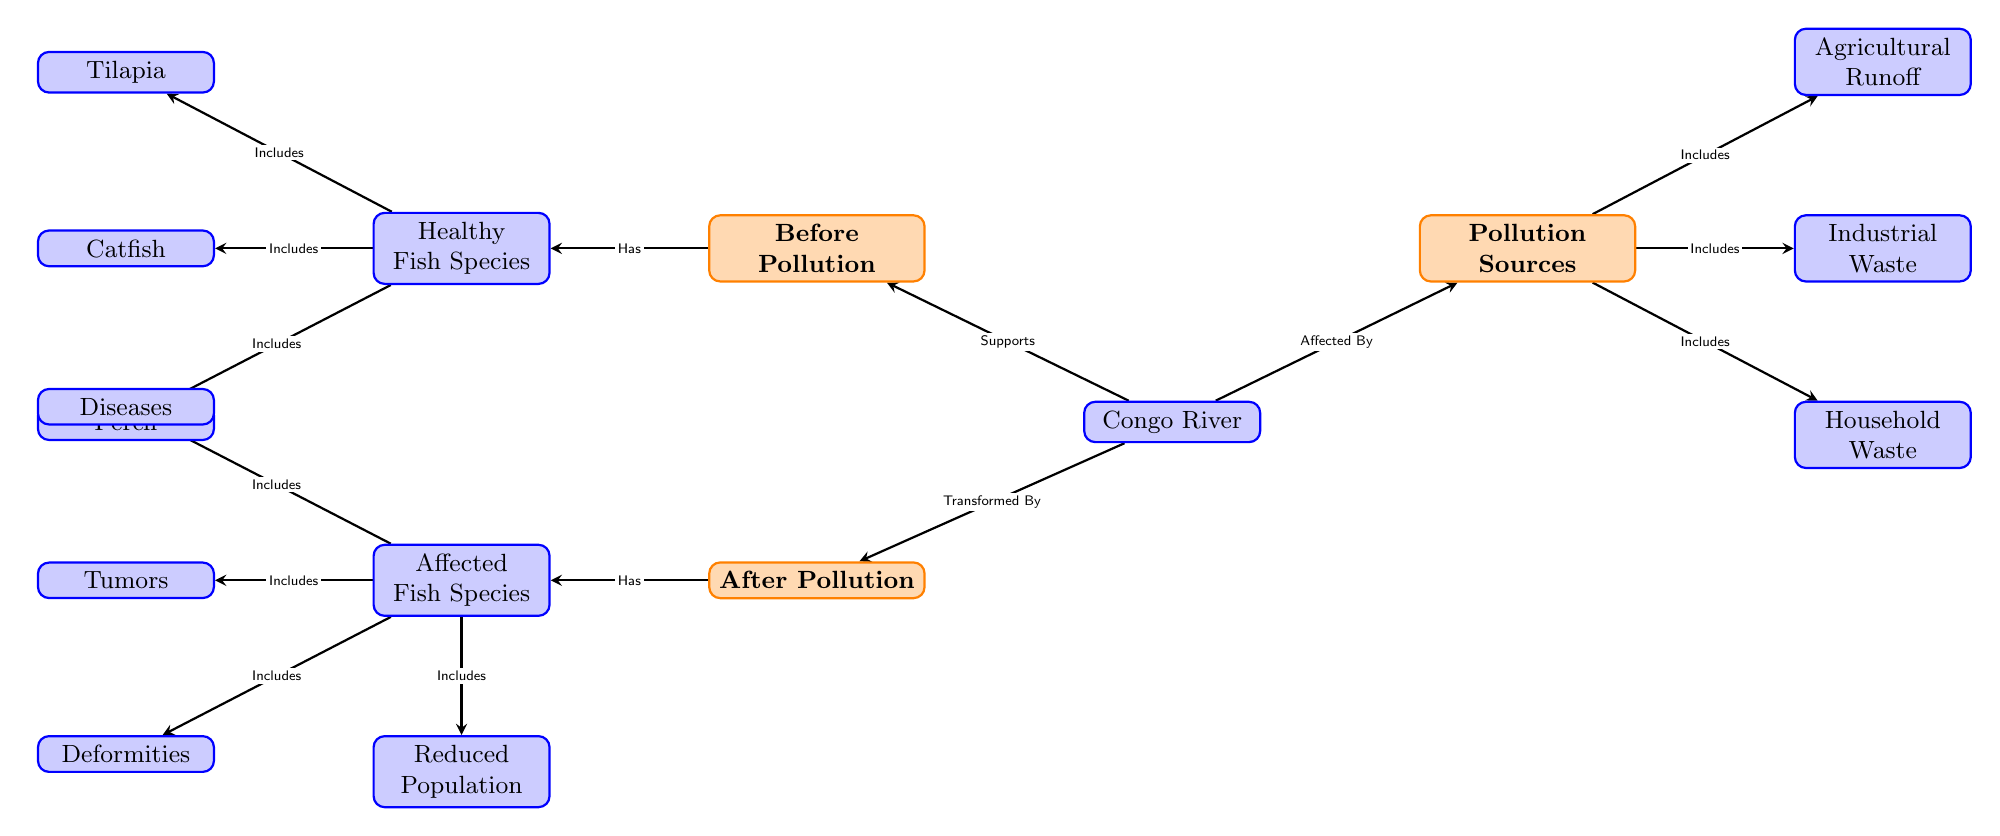What are the three pollution sources listed in the diagram? The diagram shows three pollution sources connected to the "Pollution Sources" node: "Industrial Waste," "Agricultural Runoff," and "Household Waste."
Answer: Industrial Waste, Agricultural Runoff, Household Waste How many fish species are shown as healthy before pollution? The diagram illustrates three healthy fish species connected to the "Healthy Fish Species" node: "Tilapia," "Catfish," and "Perch." Hence, there are three species depicted.
Answer: 3 What condition is linked to affected fish species after pollution? The "Affected Fish Species" node includes several conditions. The condition "Diseases" is one of them, which is directly linked to the affected fish species.
Answer: Diseases How many negative effects are listed after pollution? There are four negative effects mentioned under the "Affected Fish Species" node: "Diseases," "Tumors," "Deformities," and "Reduced Population." This leads to a total of four effects listed.
Answer: 4 Which fish species is included in the healthy category before pollution? In the "Healthy Fish Species" category, both "Tilapia" and "Catfish" are explicitly included. Thus, "Tilapia" is one of the species.
Answer: Tilapia 